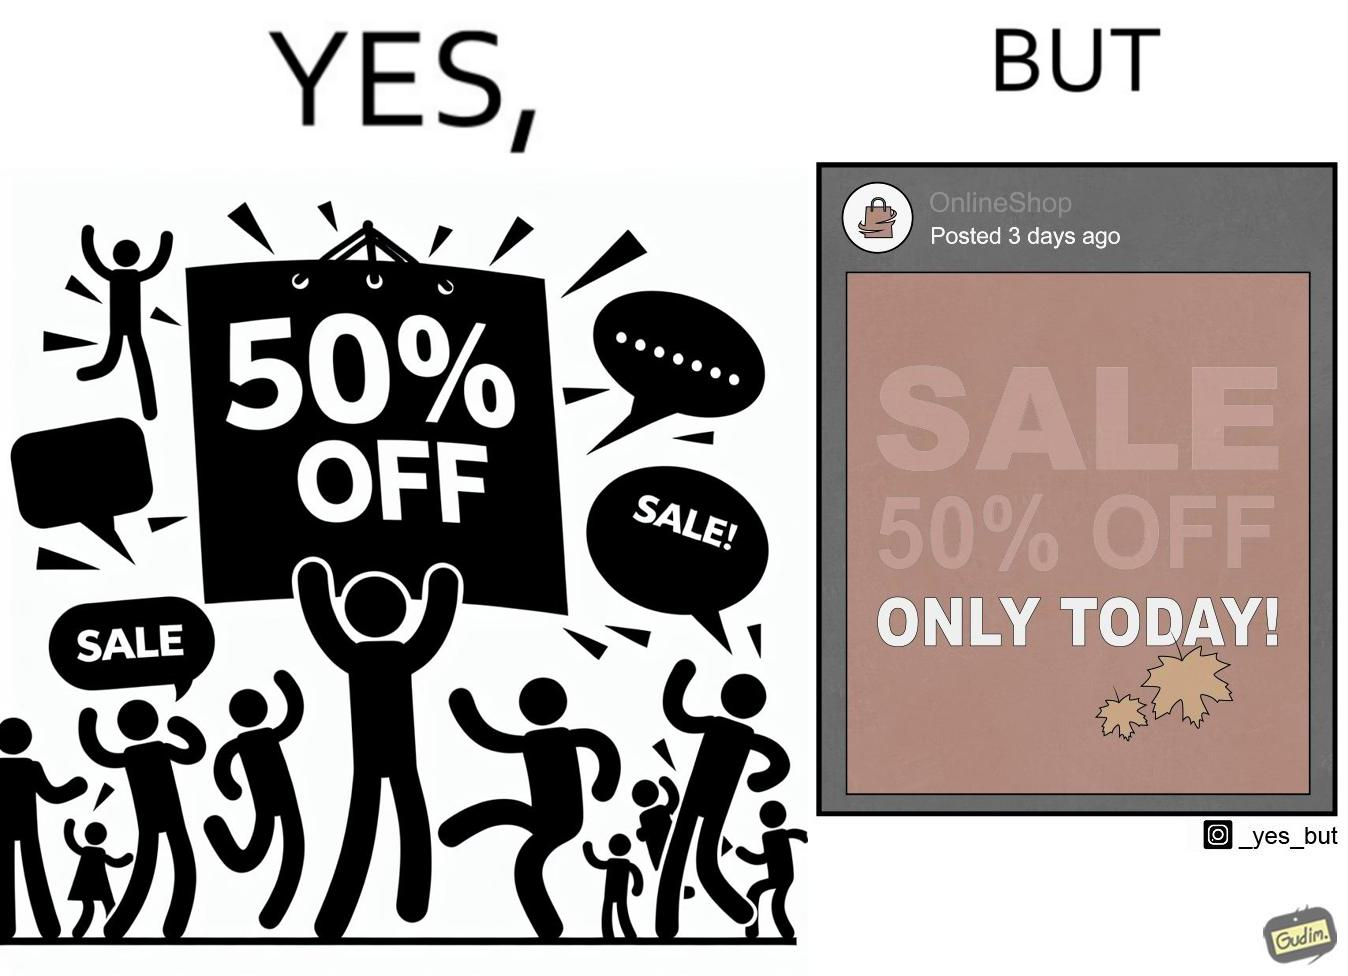Compare the left and right sides of this image. In the left part of the image: a poster suggesting a sale of 50% off on a particular day In the right part of the image: a post posted by a social media account, named as OnlineShop, 3 days ago showing an image of a poster suggesting a sale of 50% off on a particular day 